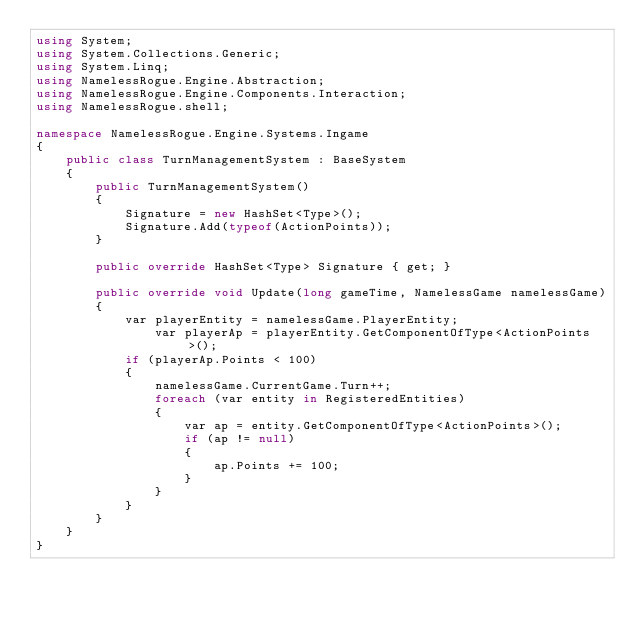<code> <loc_0><loc_0><loc_500><loc_500><_C#_>using System;
using System.Collections.Generic;
using System.Linq;
using NamelessRogue.Engine.Abstraction;
using NamelessRogue.Engine.Components.Interaction;
using NamelessRogue.shell;

namespace NamelessRogue.Engine.Systems.Ingame
{
    public class TurnManagementSystem : BaseSystem
    {
        public TurnManagementSystem()
        {
            Signature = new HashSet<Type>();
            Signature.Add(typeof(ActionPoints));
        }

        public override HashSet<Type> Signature { get; }

        public override void Update(long gameTime, NamelessGame namelessGame)
        {
            var playerEntity = namelessGame.PlayerEntity;
                var playerAp = playerEntity.GetComponentOfType<ActionPoints>();
            if (playerAp.Points < 100)
            {
                namelessGame.CurrentGame.Turn++;
                foreach (var entity in RegisteredEntities)
                {
                    var ap = entity.GetComponentOfType<ActionPoints>();
                    if (ap != null)
                    {
                        ap.Points += 100;
                    }
                }
            }
        }
    }
}
</code> 